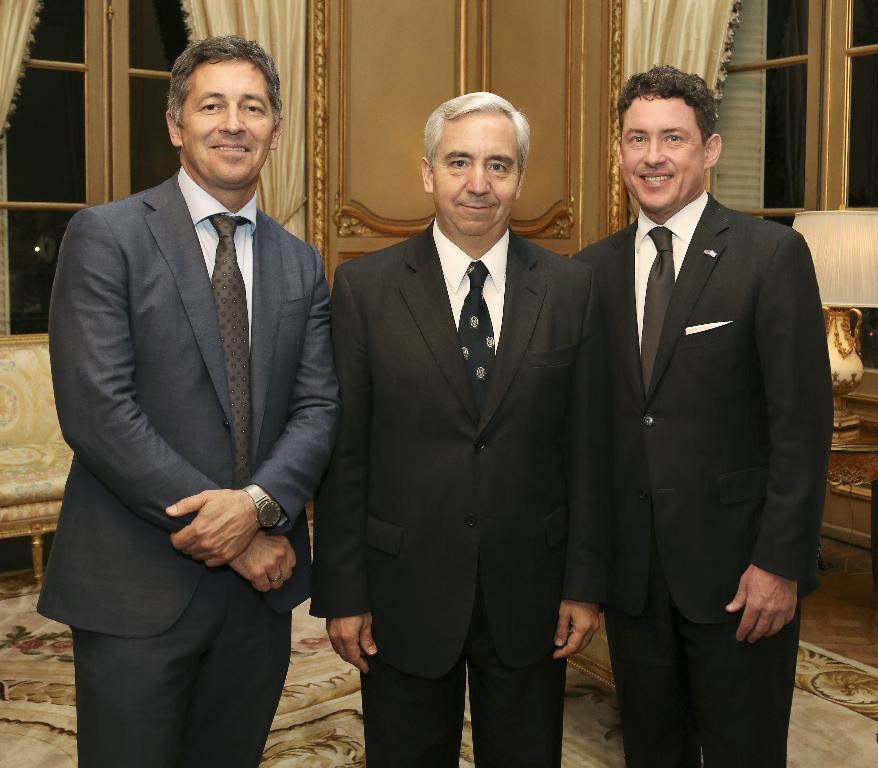Could you give a brief overview of what you see in this image? Here we see three people standing with smile on their faces all the three are wearing suits and we can see a curtain, window and a door on the back of them and even we can see a sofa set 